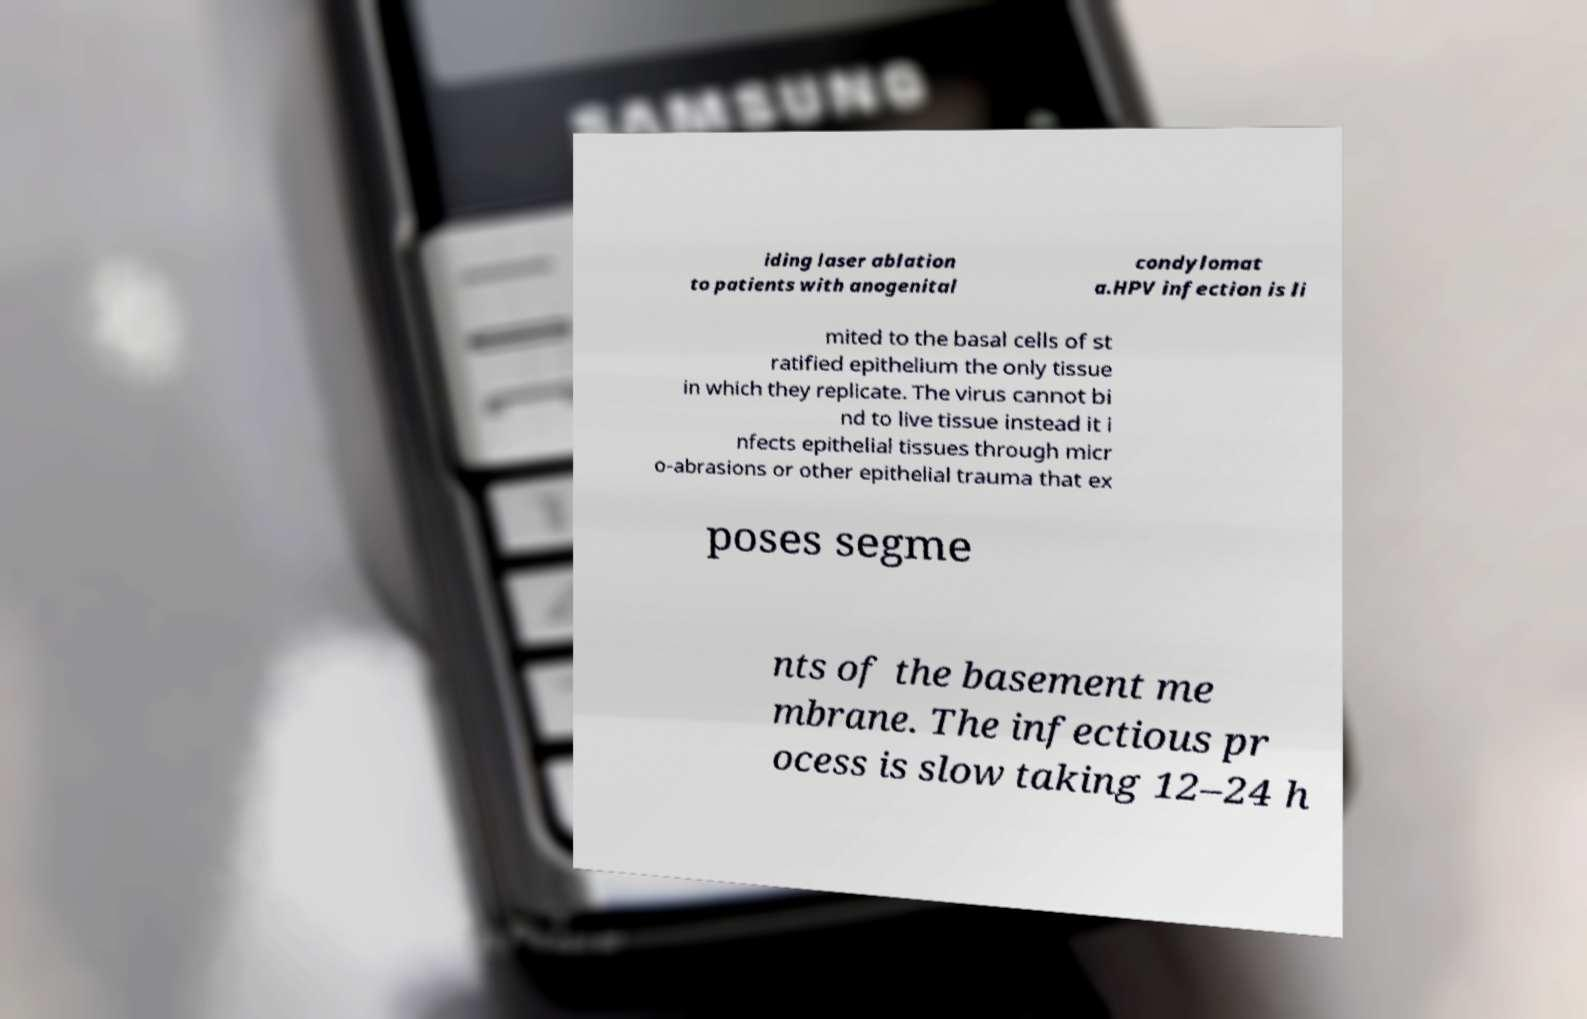Can you read and provide the text displayed in the image?This photo seems to have some interesting text. Can you extract and type it out for me? iding laser ablation to patients with anogenital condylomat a.HPV infection is li mited to the basal cells of st ratified epithelium the only tissue in which they replicate. The virus cannot bi nd to live tissue instead it i nfects epithelial tissues through micr o-abrasions or other epithelial trauma that ex poses segme nts of the basement me mbrane. The infectious pr ocess is slow taking 12–24 h 